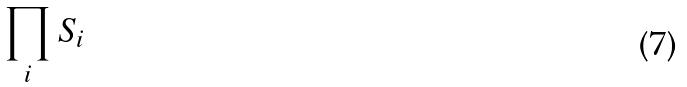<formula> <loc_0><loc_0><loc_500><loc_500>\prod _ { i } S _ { i }</formula> 